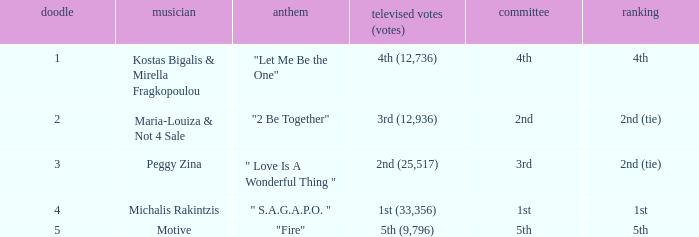Kostas Bigalis & Mirella Fragkopoulou the singer had what has the jury? 4th. 